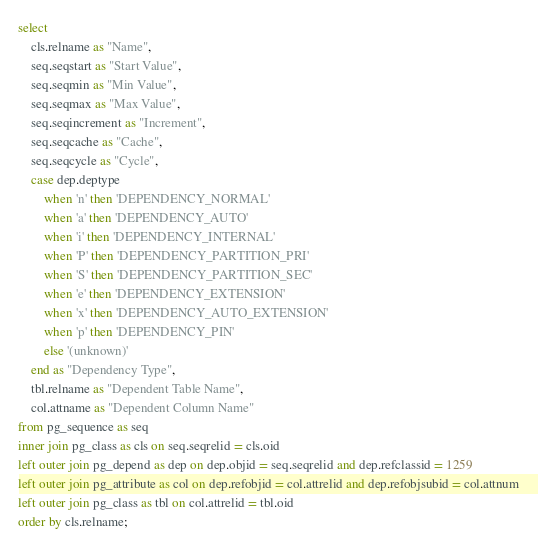Convert code to text. <code><loc_0><loc_0><loc_500><loc_500><_SQL_>select
	cls.relname as "Name",
    seq.seqstart as "Start Value",
    seq.seqmin as "Min Value",
    seq.seqmax as "Max Value",
    seq.seqincrement as "Increment",
    seq.seqcache as "Cache",
    seq.seqcycle as "Cycle",
	case dep.deptype
    	when 'n' then 'DEPENDENCY_NORMAL'
    	when 'a' then 'DEPENDENCY_AUTO'
    	when 'i' then 'DEPENDENCY_INTERNAL'
    	when 'P' then 'DEPENDENCY_PARTITION_PRI'
    	when 'S' then 'DEPENDENCY_PARTITION_SEC'
    	when 'e' then 'DEPENDENCY_EXTENSION'
    	when 'x' then 'DEPENDENCY_AUTO_EXTENSION'
    	when 'p' then 'DEPENDENCY_PIN'
    	else '(unknown)'
    end as "Dependency Type",
    tbl.relname as "Dependent Table Name",
    col.attname as "Dependent Column Name"
from pg_sequence as seq
inner join pg_class as cls on seq.seqrelid = cls.oid
left outer join pg_depend as dep on dep.objid = seq.seqrelid and dep.refclassid = 1259
left outer join pg_attribute as col on dep.refobjid = col.attrelid and dep.refobjsubid = col.attnum
left outer join pg_class as tbl on col.attrelid = tbl.oid
order by cls.relname;
</code> 